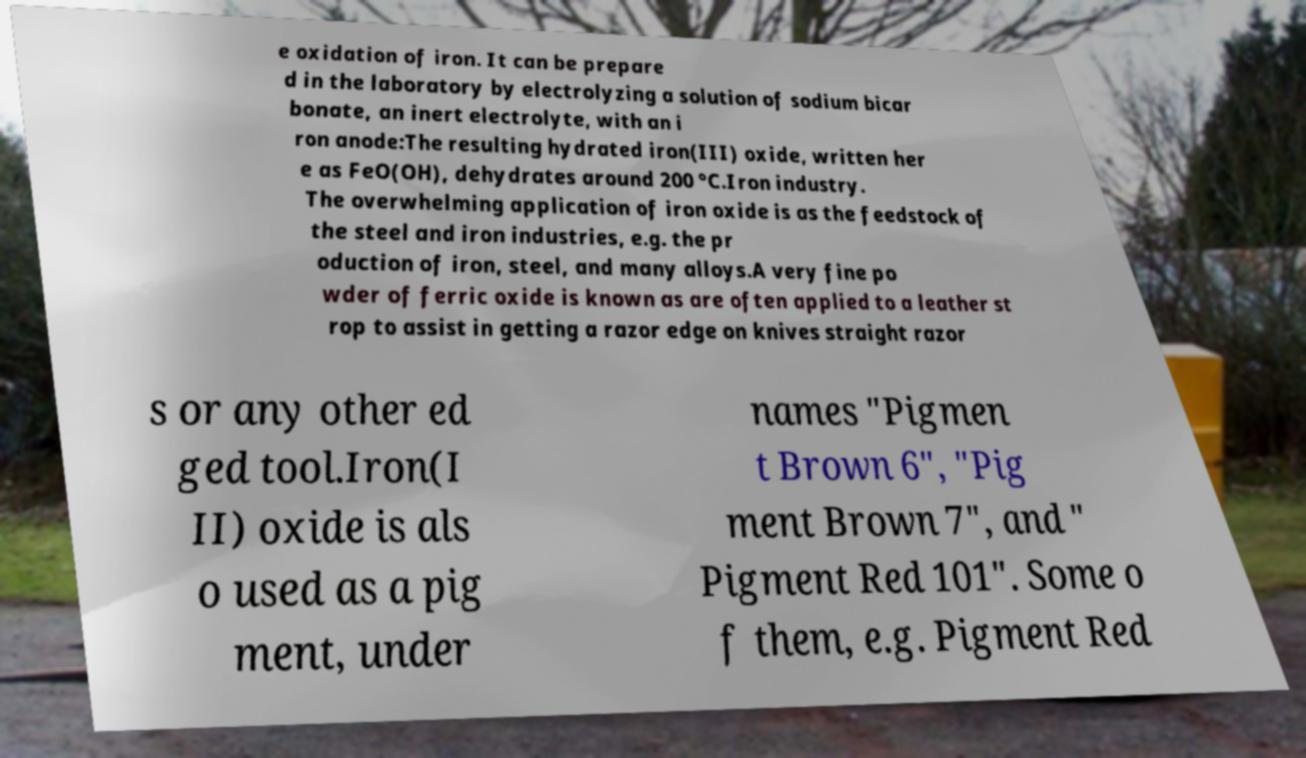Could you assist in decoding the text presented in this image and type it out clearly? e oxidation of iron. It can be prepare d in the laboratory by electrolyzing a solution of sodium bicar bonate, an inert electrolyte, with an i ron anode:The resulting hydrated iron(III) oxide, written her e as FeO(OH), dehydrates around 200 °C.Iron industry. The overwhelming application of iron oxide is as the feedstock of the steel and iron industries, e.g. the pr oduction of iron, steel, and many alloys.A very fine po wder of ferric oxide is known as are often applied to a leather st rop to assist in getting a razor edge on knives straight razor s or any other ed ged tool.Iron(I II) oxide is als o used as a pig ment, under names "Pigmen t Brown 6", "Pig ment Brown 7", and " Pigment Red 101". Some o f them, e.g. Pigment Red 